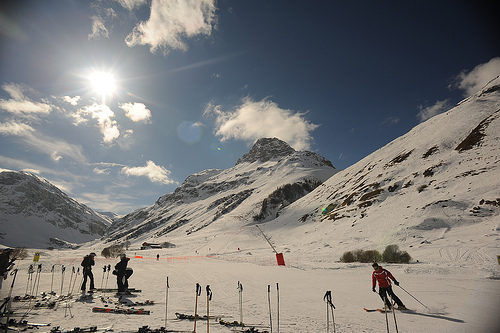What kind of skiing activities does the image suggest are popular in this area? The image suggests that alpine skiing is popular, evidenced by the skiers using downhill ski gear and the marked ski runs visible. Are there any safety measures noticeable in the area? Yes, safety measures include the presence of orange safety fences and clear signage, as well as the observance of skiing lanes to guide and protect the skiers. 